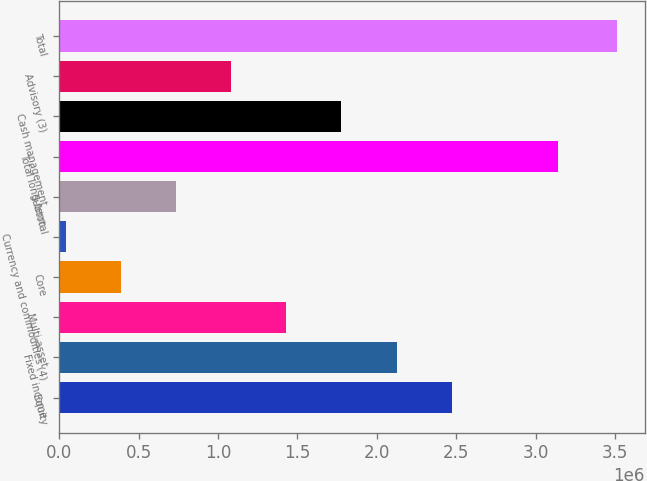Convert chart to OTSL. <chart><loc_0><loc_0><loc_500><loc_500><bar_chart><fcel>Equity<fcel>Fixed income<fcel>Multi-asset<fcel>Core<fcel>Currency and commodities (4)<fcel>Subtotal<fcel>Total long-term<fcel>Cash management<fcel>Advisory (3)<fcel>Total<nl><fcel>2.47127e+06<fcel>2.12413e+06<fcel>1.42985e+06<fcel>388439<fcel>41301<fcel>735577<fcel>3.13795e+06<fcel>1.77699e+06<fcel>1.08272e+06<fcel>3.51268e+06<nl></chart> 